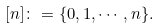Convert formula to latex. <formula><loc_0><loc_0><loc_500><loc_500>[ n ] \colon = \{ 0 , 1 , \cdots , n \} .</formula> 